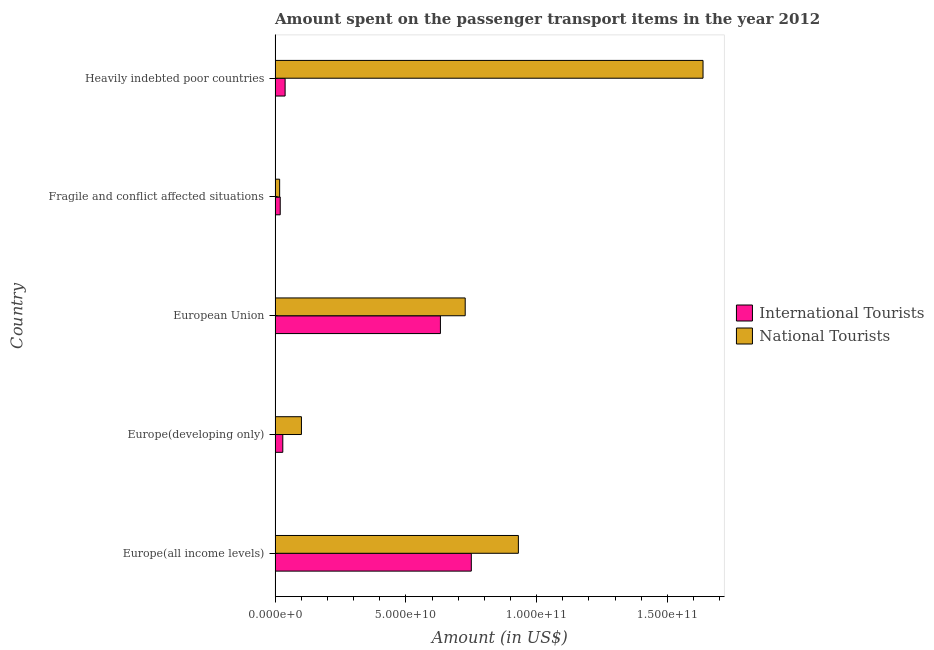How many different coloured bars are there?
Offer a terse response. 2. How many groups of bars are there?
Offer a very short reply. 5. How many bars are there on the 3rd tick from the bottom?
Your response must be concise. 2. What is the amount spent on transport items of national tourists in Heavily indebted poor countries?
Make the answer very short. 1.64e+11. Across all countries, what is the maximum amount spent on transport items of national tourists?
Give a very brief answer. 1.64e+11. Across all countries, what is the minimum amount spent on transport items of international tourists?
Your answer should be very brief. 1.97e+09. In which country was the amount spent on transport items of international tourists maximum?
Keep it short and to the point. Europe(all income levels). In which country was the amount spent on transport items of international tourists minimum?
Offer a terse response. Fragile and conflict affected situations. What is the total amount spent on transport items of international tourists in the graph?
Keep it short and to the point. 1.47e+11. What is the difference between the amount spent on transport items of international tourists in European Union and that in Fragile and conflict affected situations?
Provide a short and direct response. 6.13e+1. What is the difference between the amount spent on transport items of national tourists in Europe(all income levels) and the amount spent on transport items of international tourists in European Union?
Make the answer very short. 2.98e+1. What is the average amount spent on transport items of national tourists per country?
Make the answer very short. 6.82e+1. What is the difference between the amount spent on transport items of national tourists and amount spent on transport items of international tourists in Fragile and conflict affected situations?
Ensure brevity in your answer.  -2.22e+08. What is the ratio of the amount spent on transport items of national tourists in European Union to that in Heavily indebted poor countries?
Your response must be concise. 0.44. Is the difference between the amount spent on transport items of international tourists in Fragile and conflict affected situations and Heavily indebted poor countries greater than the difference between the amount spent on transport items of national tourists in Fragile and conflict affected situations and Heavily indebted poor countries?
Ensure brevity in your answer.  Yes. What is the difference between the highest and the second highest amount spent on transport items of international tourists?
Your response must be concise. 1.18e+1. What is the difference between the highest and the lowest amount spent on transport items of international tourists?
Give a very brief answer. 7.31e+1. In how many countries, is the amount spent on transport items of international tourists greater than the average amount spent on transport items of international tourists taken over all countries?
Offer a terse response. 2. What does the 2nd bar from the top in European Union represents?
Offer a terse response. International Tourists. What does the 1st bar from the bottom in Europe(developing only) represents?
Provide a short and direct response. International Tourists. Does the graph contain any zero values?
Your response must be concise. No. Does the graph contain grids?
Give a very brief answer. No. Where does the legend appear in the graph?
Your answer should be compact. Center right. What is the title of the graph?
Provide a short and direct response. Amount spent on the passenger transport items in the year 2012. Does "Arms imports" appear as one of the legend labels in the graph?
Your answer should be very brief. No. What is the label or title of the X-axis?
Make the answer very short. Amount (in US$). What is the label or title of the Y-axis?
Make the answer very short. Country. What is the Amount (in US$) of International Tourists in Europe(all income levels)?
Make the answer very short. 7.50e+1. What is the Amount (in US$) of National Tourists in Europe(all income levels)?
Make the answer very short. 9.30e+1. What is the Amount (in US$) in International Tourists in Europe(developing only)?
Offer a terse response. 2.95e+09. What is the Amount (in US$) in National Tourists in Europe(developing only)?
Ensure brevity in your answer.  1.01e+1. What is the Amount (in US$) of International Tourists in European Union?
Provide a succinct answer. 6.32e+1. What is the Amount (in US$) in National Tourists in European Union?
Ensure brevity in your answer.  7.27e+1. What is the Amount (in US$) of International Tourists in Fragile and conflict affected situations?
Offer a terse response. 1.97e+09. What is the Amount (in US$) of National Tourists in Fragile and conflict affected situations?
Your response must be concise. 1.75e+09. What is the Amount (in US$) of International Tourists in Heavily indebted poor countries?
Keep it short and to the point. 3.83e+09. What is the Amount (in US$) of National Tourists in Heavily indebted poor countries?
Provide a short and direct response. 1.64e+11. Across all countries, what is the maximum Amount (in US$) in International Tourists?
Provide a succinct answer. 7.50e+1. Across all countries, what is the maximum Amount (in US$) in National Tourists?
Provide a short and direct response. 1.64e+11. Across all countries, what is the minimum Amount (in US$) of International Tourists?
Your response must be concise. 1.97e+09. Across all countries, what is the minimum Amount (in US$) in National Tourists?
Offer a terse response. 1.75e+09. What is the total Amount (in US$) in International Tourists in the graph?
Ensure brevity in your answer.  1.47e+11. What is the total Amount (in US$) of National Tourists in the graph?
Ensure brevity in your answer.  3.41e+11. What is the difference between the Amount (in US$) of International Tourists in Europe(all income levels) and that in Europe(developing only)?
Provide a succinct answer. 7.21e+1. What is the difference between the Amount (in US$) of National Tourists in Europe(all income levels) and that in Europe(developing only)?
Your answer should be compact. 8.30e+1. What is the difference between the Amount (in US$) in International Tourists in Europe(all income levels) and that in European Union?
Provide a succinct answer. 1.18e+1. What is the difference between the Amount (in US$) in National Tourists in Europe(all income levels) and that in European Union?
Keep it short and to the point. 2.03e+1. What is the difference between the Amount (in US$) in International Tourists in Europe(all income levels) and that in Fragile and conflict affected situations?
Provide a short and direct response. 7.31e+1. What is the difference between the Amount (in US$) of National Tourists in Europe(all income levels) and that in Fragile and conflict affected situations?
Keep it short and to the point. 9.13e+1. What is the difference between the Amount (in US$) of International Tourists in Europe(all income levels) and that in Heavily indebted poor countries?
Offer a terse response. 7.12e+1. What is the difference between the Amount (in US$) of National Tourists in Europe(all income levels) and that in Heavily indebted poor countries?
Keep it short and to the point. -7.06e+1. What is the difference between the Amount (in US$) in International Tourists in Europe(developing only) and that in European Union?
Provide a succinct answer. -6.03e+1. What is the difference between the Amount (in US$) of National Tourists in Europe(developing only) and that in European Union?
Provide a short and direct response. -6.26e+1. What is the difference between the Amount (in US$) of International Tourists in Europe(developing only) and that in Fragile and conflict affected situations?
Keep it short and to the point. 9.84e+08. What is the difference between the Amount (in US$) of National Tourists in Europe(developing only) and that in Fragile and conflict affected situations?
Keep it short and to the point. 8.33e+09. What is the difference between the Amount (in US$) in International Tourists in Europe(developing only) and that in Heavily indebted poor countries?
Ensure brevity in your answer.  -8.81e+08. What is the difference between the Amount (in US$) of National Tourists in Europe(developing only) and that in Heavily indebted poor countries?
Make the answer very short. -1.54e+11. What is the difference between the Amount (in US$) in International Tourists in European Union and that in Fragile and conflict affected situations?
Provide a short and direct response. 6.13e+1. What is the difference between the Amount (in US$) in National Tourists in European Union and that in Fragile and conflict affected situations?
Offer a terse response. 7.10e+1. What is the difference between the Amount (in US$) in International Tourists in European Union and that in Heavily indebted poor countries?
Provide a succinct answer. 5.94e+1. What is the difference between the Amount (in US$) of National Tourists in European Union and that in Heavily indebted poor countries?
Make the answer very short. -9.09e+1. What is the difference between the Amount (in US$) of International Tourists in Fragile and conflict affected situations and that in Heavily indebted poor countries?
Make the answer very short. -1.86e+09. What is the difference between the Amount (in US$) in National Tourists in Fragile and conflict affected situations and that in Heavily indebted poor countries?
Make the answer very short. -1.62e+11. What is the difference between the Amount (in US$) in International Tourists in Europe(all income levels) and the Amount (in US$) in National Tourists in Europe(developing only)?
Make the answer very short. 6.50e+1. What is the difference between the Amount (in US$) in International Tourists in Europe(all income levels) and the Amount (in US$) in National Tourists in European Union?
Give a very brief answer. 2.33e+09. What is the difference between the Amount (in US$) in International Tourists in Europe(all income levels) and the Amount (in US$) in National Tourists in Fragile and conflict affected situations?
Ensure brevity in your answer.  7.33e+1. What is the difference between the Amount (in US$) in International Tourists in Europe(all income levels) and the Amount (in US$) in National Tourists in Heavily indebted poor countries?
Your answer should be very brief. -8.86e+1. What is the difference between the Amount (in US$) of International Tourists in Europe(developing only) and the Amount (in US$) of National Tourists in European Union?
Keep it short and to the point. -6.97e+1. What is the difference between the Amount (in US$) of International Tourists in Europe(developing only) and the Amount (in US$) of National Tourists in Fragile and conflict affected situations?
Give a very brief answer. 1.21e+09. What is the difference between the Amount (in US$) of International Tourists in Europe(developing only) and the Amount (in US$) of National Tourists in Heavily indebted poor countries?
Your response must be concise. -1.61e+11. What is the difference between the Amount (in US$) in International Tourists in European Union and the Amount (in US$) in National Tourists in Fragile and conflict affected situations?
Your answer should be compact. 6.15e+1. What is the difference between the Amount (in US$) of International Tourists in European Union and the Amount (in US$) of National Tourists in Heavily indebted poor countries?
Offer a very short reply. -1.00e+11. What is the difference between the Amount (in US$) of International Tourists in Fragile and conflict affected situations and the Amount (in US$) of National Tourists in Heavily indebted poor countries?
Give a very brief answer. -1.62e+11. What is the average Amount (in US$) in International Tourists per country?
Offer a terse response. 2.94e+1. What is the average Amount (in US$) of National Tourists per country?
Offer a terse response. 6.82e+1. What is the difference between the Amount (in US$) of International Tourists and Amount (in US$) of National Tourists in Europe(all income levels)?
Your answer should be very brief. -1.80e+1. What is the difference between the Amount (in US$) in International Tourists and Amount (in US$) in National Tourists in Europe(developing only)?
Keep it short and to the point. -7.13e+09. What is the difference between the Amount (in US$) of International Tourists and Amount (in US$) of National Tourists in European Union?
Give a very brief answer. -9.48e+09. What is the difference between the Amount (in US$) of International Tourists and Amount (in US$) of National Tourists in Fragile and conflict affected situations?
Make the answer very short. 2.22e+08. What is the difference between the Amount (in US$) in International Tourists and Amount (in US$) in National Tourists in Heavily indebted poor countries?
Provide a succinct answer. -1.60e+11. What is the ratio of the Amount (in US$) in International Tourists in Europe(all income levels) to that in Europe(developing only)?
Provide a short and direct response. 25.41. What is the ratio of the Amount (in US$) in National Tourists in Europe(all income levels) to that in Europe(developing only)?
Offer a terse response. 9.23. What is the ratio of the Amount (in US$) of International Tourists in Europe(all income levels) to that in European Union?
Provide a succinct answer. 1.19. What is the ratio of the Amount (in US$) in National Tourists in Europe(all income levels) to that in European Union?
Ensure brevity in your answer.  1.28. What is the ratio of the Amount (in US$) in International Tourists in Europe(all income levels) to that in Fragile and conflict affected situations?
Your answer should be very brief. 38.11. What is the ratio of the Amount (in US$) of National Tourists in Europe(all income levels) to that in Fragile and conflict affected situations?
Ensure brevity in your answer.  53.27. What is the ratio of the Amount (in US$) in International Tourists in Europe(all income levels) to that in Heavily indebted poor countries?
Make the answer very short. 19.57. What is the ratio of the Amount (in US$) of National Tourists in Europe(all income levels) to that in Heavily indebted poor countries?
Keep it short and to the point. 0.57. What is the ratio of the Amount (in US$) in International Tourists in Europe(developing only) to that in European Union?
Your answer should be compact. 0.05. What is the ratio of the Amount (in US$) in National Tourists in Europe(developing only) to that in European Union?
Your answer should be very brief. 0.14. What is the ratio of the Amount (in US$) of International Tourists in Europe(developing only) to that in Fragile and conflict affected situations?
Ensure brevity in your answer.  1.5. What is the ratio of the Amount (in US$) of National Tourists in Europe(developing only) to that in Fragile and conflict affected situations?
Provide a succinct answer. 5.77. What is the ratio of the Amount (in US$) in International Tourists in Europe(developing only) to that in Heavily indebted poor countries?
Provide a short and direct response. 0.77. What is the ratio of the Amount (in US$) of National Tourists in Europe(developing only) to that in Heavily indebted poor countries?
Offer a very short reply. 0.06. What is the ratio of the Amount (in US$) of International Tourists in European Union to that in Fragile and conflict affected situations?
Your answer should be very brief. 32.11. What is the ratio of the Amount (in US$) of National Tourists in European Union to that in Fragile and conflict affected situations?
Your response must be concise. 41.63. What is the ratio of the Amount (in US$) of International Tourists in European Union to that in Heavily indebted poor countries?
Your answer should be compact. 16.49. What is the ratio of the Amount (in US$) of National Tourists in European Union to that in Heavily indebted poor countries?
Make the answer very short. 0.44. What is the ratio of the Amount (in US$) in International Tourists in Fragile and conflict affected situations to that in Heavily indebted poor countries?
Your answer should be compact. 0.51. What is the ratio of the Amount (in US$) of National Tourists in Fragile and conflict affected situations to that in Heavily indebted poor countries?
Provide a succinct answer. 0.01. What is the difference between the highest and the second highest Amount (in US$) in International Tourists?
Make the answer very short. 1.18e+1. What is the difference between the highest and the second highest Amount (in US$) of National Tourists?
Offer a terse response. 7.06e+1. What is the difference between the highest and the lowest Amount (in US$) in International Tourists?
Your response must be concise. 7.31e+1. What is the difference between the highest and the lowest Amount (in US$) of National Tourists?
Keep it short and to the point. 1.62e+11. 